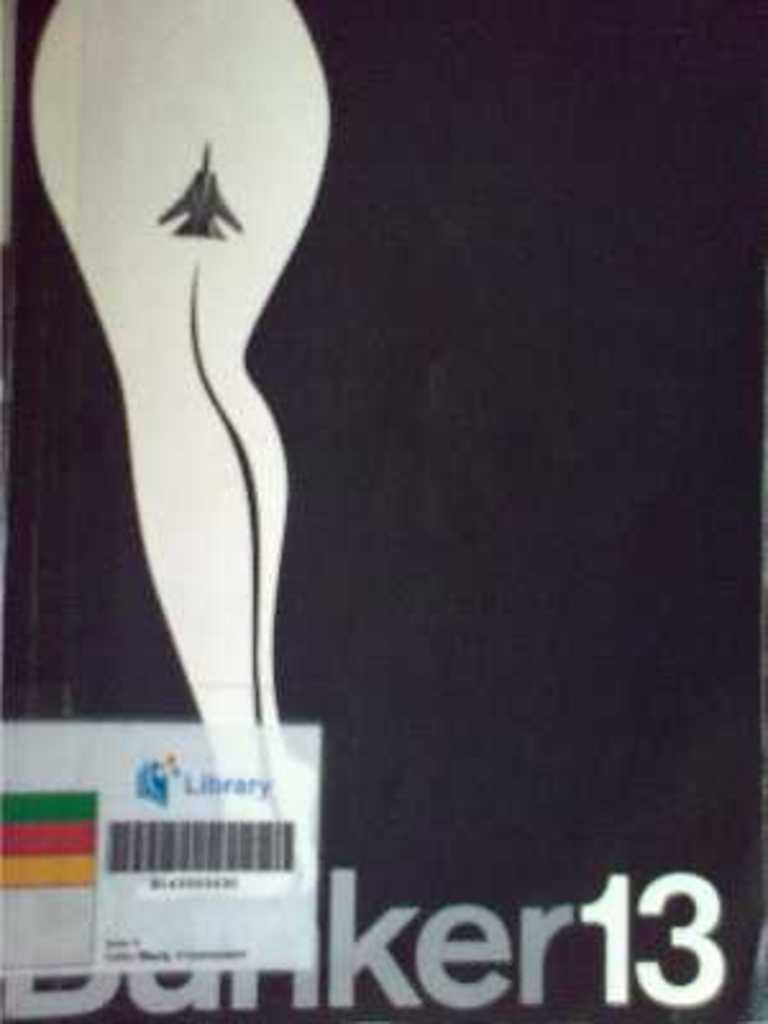<image>
Provide a brief description of the given image. A black poster with Bunker 13 written at the bottom and a silhouette of a woman on the left. 